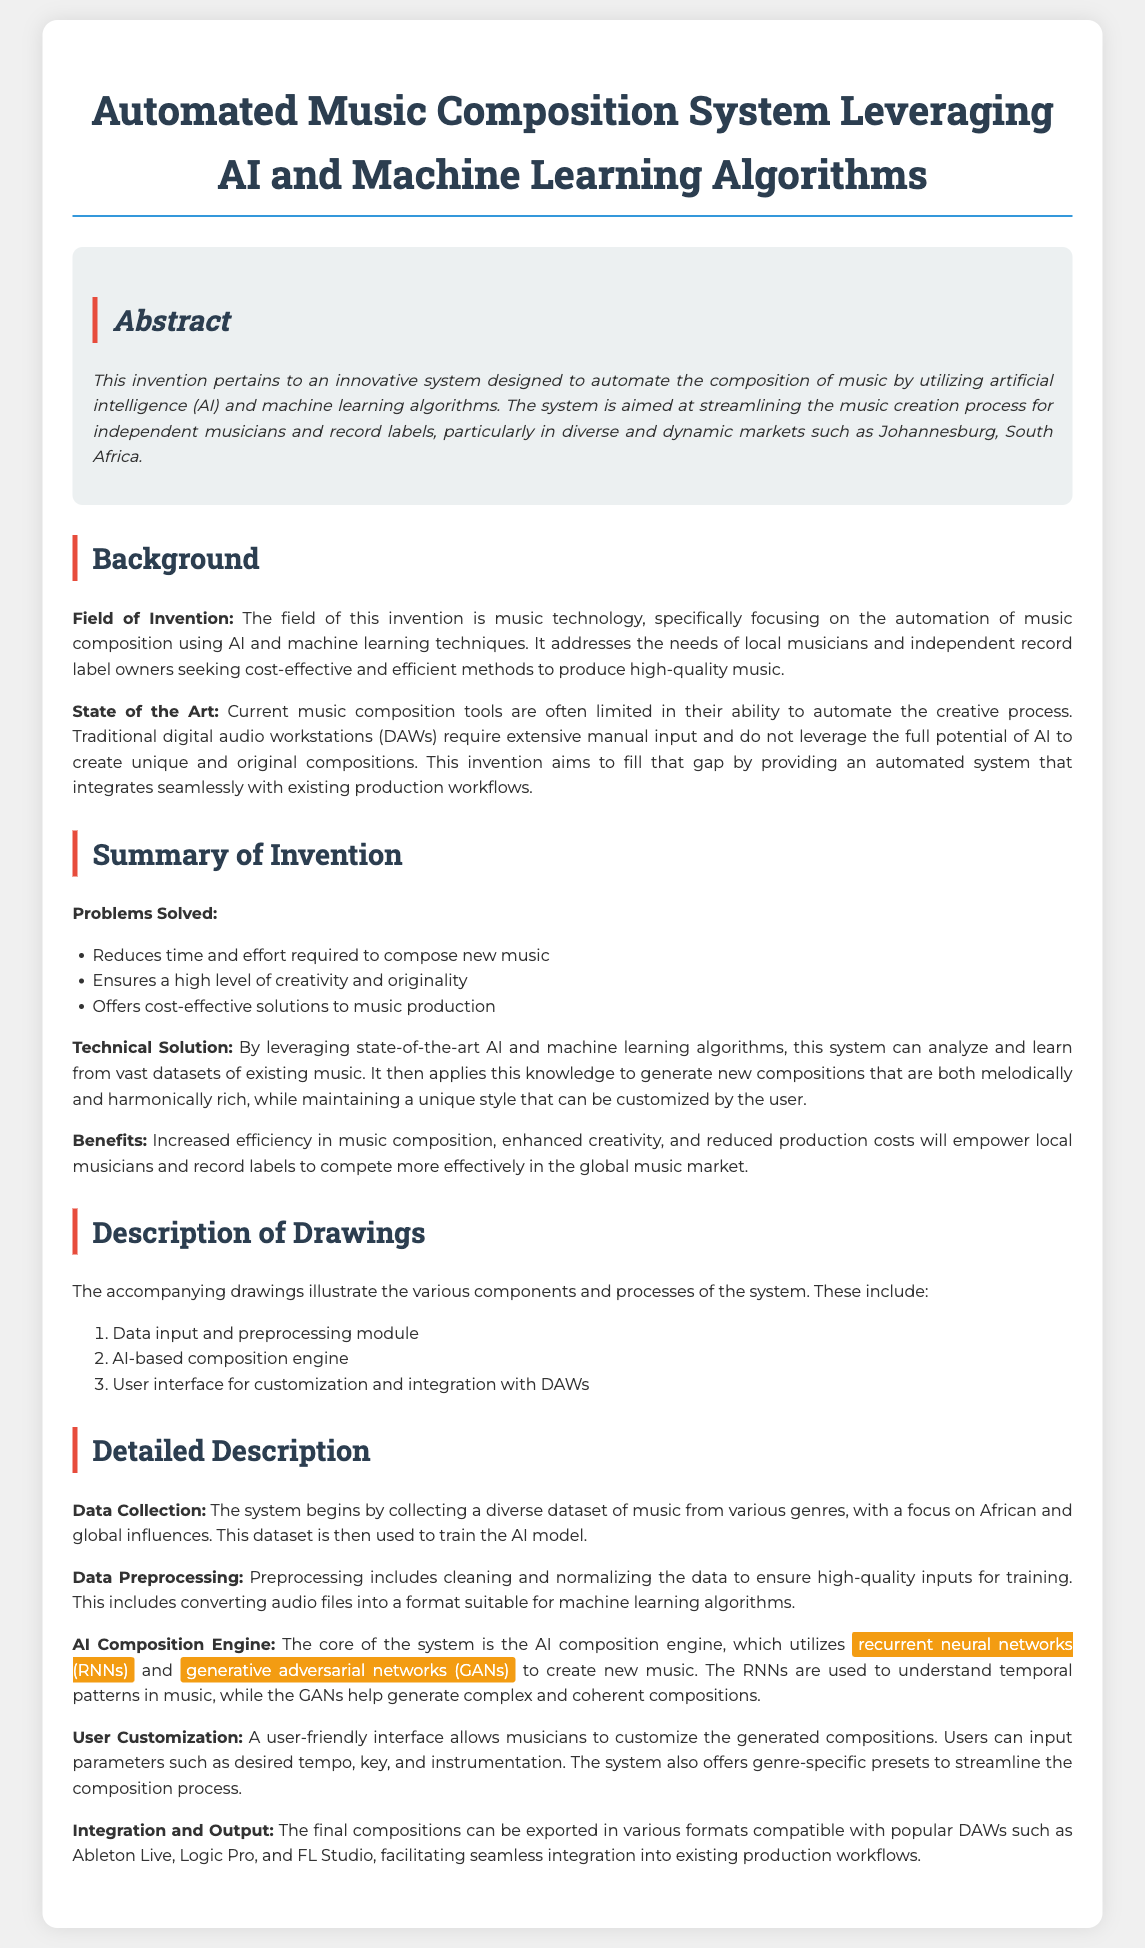what is the title of the patent application? The title is the main heading of the document, which defines the subject matter of the invention.
Answer: Automated Music Composition System Leveraging AI and Machine Learning Algorithms what is the main purpose of the invention? The main purpose is highlighted in the abstract, which summarizes the invention's function.
Answer: Automate the composition of music which two AI techniques are mentioned in the detailed description? These techniques are specified in the AI Composition Engine section, indicating the core technologies used.
Answer: recurrent neural networks and generative adversarial networks what are the problems solved by this invention? The problems addressed are listed in the Summary of Invention section.
Answer: Reduces time and effort; creativity and originality; cost-effective solutions what type of music does the system focus on for the dataset? This focuses on the types of music mentioned in the Data Collection section, specifying the influence on the training dataset.
Answer: African and global influences how many components are listed in the Description of Drawings? The number of components is provided in the accompanying list under Description of Drawings.
Answer: Three which existing tools does the invention aim to improve upon? The existing tools are mentioned in the State of the Art section, pointing out limitations of current technologies.
Answer: Traditional digital audio workstations what is the intended target audience for this system? The target audience is described in the abstract, defining who would benefit the most from the invention.
Answer: Independent musicians and record labels 